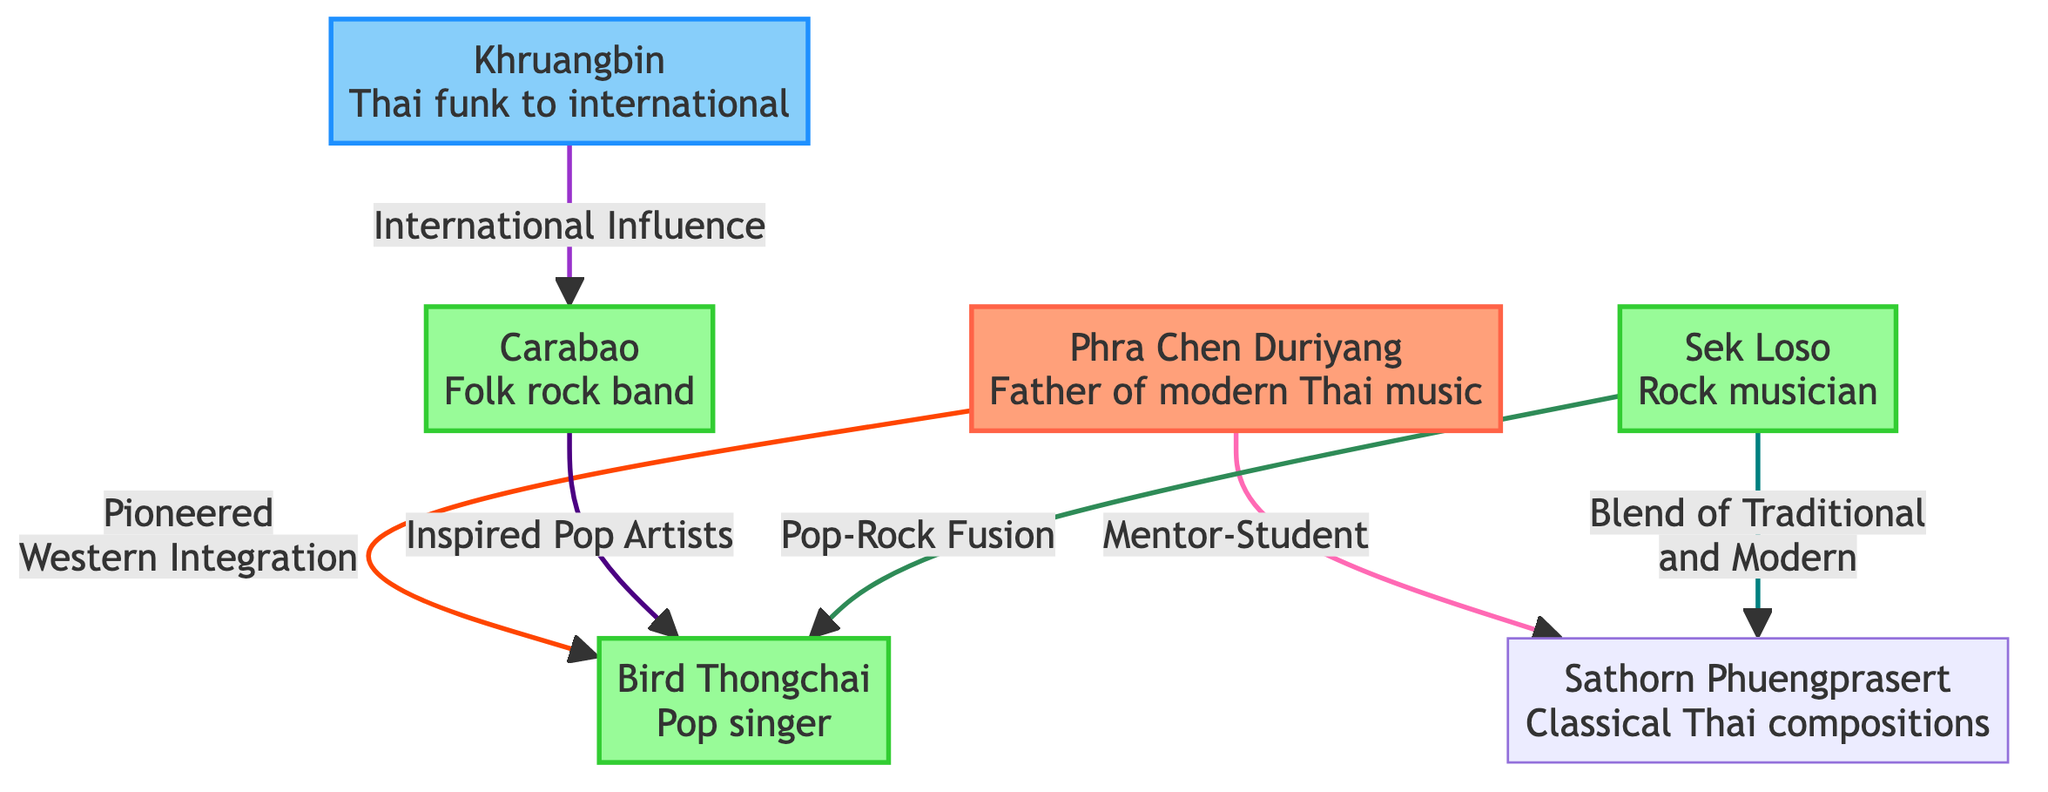What is the title given to Phra Chen Duriyang in the diagram? The diagram describes Phra Chen Duriyang as the "Father of modern Thai music." This title is directly stated in the node associated with Phra Chen Duriyang.
Answer: Father of modern Thai music How many musicians or bands are classified as "modern"? The diagram includes three entities that are labeled as "modern" (Carabao, Bird Thongchai, and Sek Loso). By counting the nodes with the classification 'modern,' we can determine the number.
Answer: 3 Who is depicted as the father of modern Thai music, and what role does he have with Sathorn Phuengprasert? Phra Chen Duriyang is depicted as the father of modern Thai music, and he has a "Mentor-Student" relationship with Sathorn Phuengprasert, as indicated by the connecting line between the two nodes.
Answer: Phra Chen Duriyang (Mentor) Which musician is described as having “International Influence”? The diagram notes that Khruangbin has an "International Influence" on Carabao, connecting them with a directed edge labeled as such. This indicates that Khruangbin's music has been influential on the noted band.
Answer: Khruangbin How many different colored classes are used to categorize the musicians and bands? The diagram utilizes three distinct colored classes to classify the musicians and bands: pioneer (for Phra Chen Duriyang), modern (for Carabao, Bird Thongchai, Sek Loso), and international (for Khruangbin). Counting these indicates the variety of classifications present.
Answer: 3 Which two musicians are connected by the term “Pop-Rock Fusion”? The diagram shows a connection between Sek Loso and Bird Thongchai with the term "Pop-Rock Fusion," indicating that their musical styles influence or blend together within this context.
Answer: Sek Loso and Bird Thongchai What significant contribution is noted for Bird Thongchai in relation to Phra Chen Duriyang? The diagram indicates that Phra Chen Duriyang "Pioneered Western Integration" for Bird Thongchai, showing an influential contribution to his development as a modern artist.
Answer: Pioneered Western Integration Which band is considered a folk rock band? In the diagram, Carabao is specifically labeled as a "Folk rock band," making it clear that this is their designated genre within the music landscape of Thailand.
Answer: Carabao What relationship does Sek Loso have with Sathorn Phuengprasert according to the diagram? The diagram indicates that Sek Loso has a "Blend of Traditional and Modern" relationship with Sathorn Phuengprasert, suggesting a fusion of styles between the rock musician and the classical composer.
Answer: Blend of Traditional and Modern 